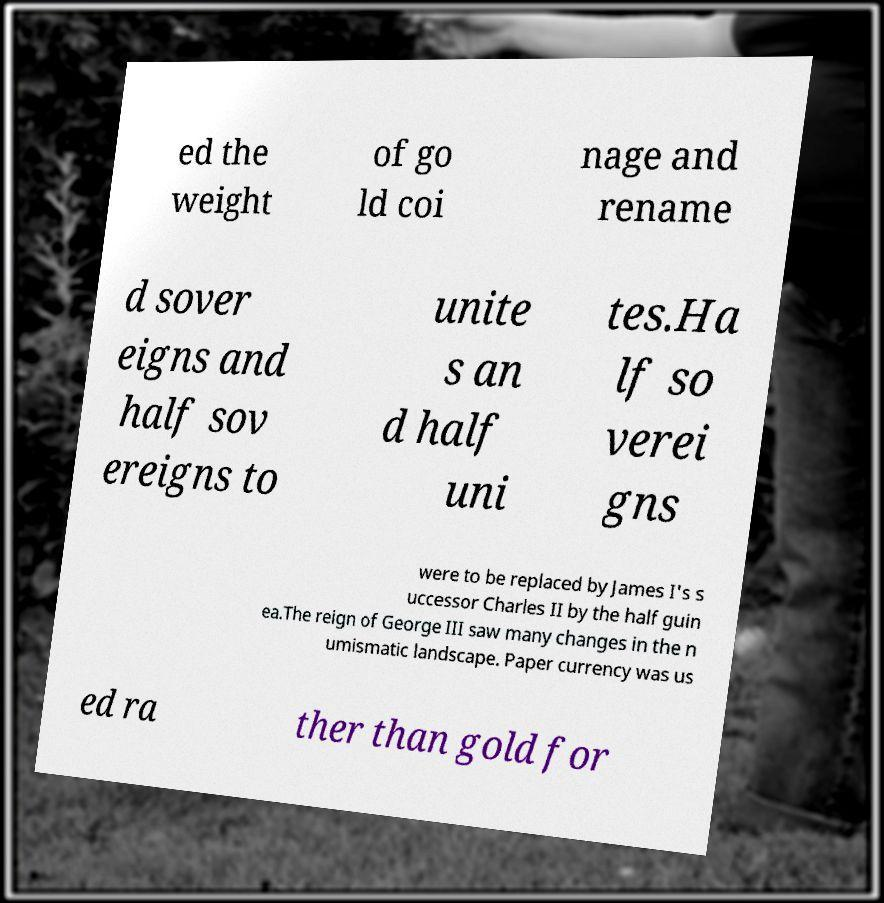What messages or text are displayed in this image? I need them in a readable, typed format. ed the weight of go ld coi nage and rename d sover eigns and half sov ereigns to unite s an d half uni tes.Ha lf so verei gns were to be replaced by James I's s uccessor Charles II by the half guin ea.The reign of George III saw many changes in the n umismatic landscape. Paper currency was us ed ra ther than gold for 